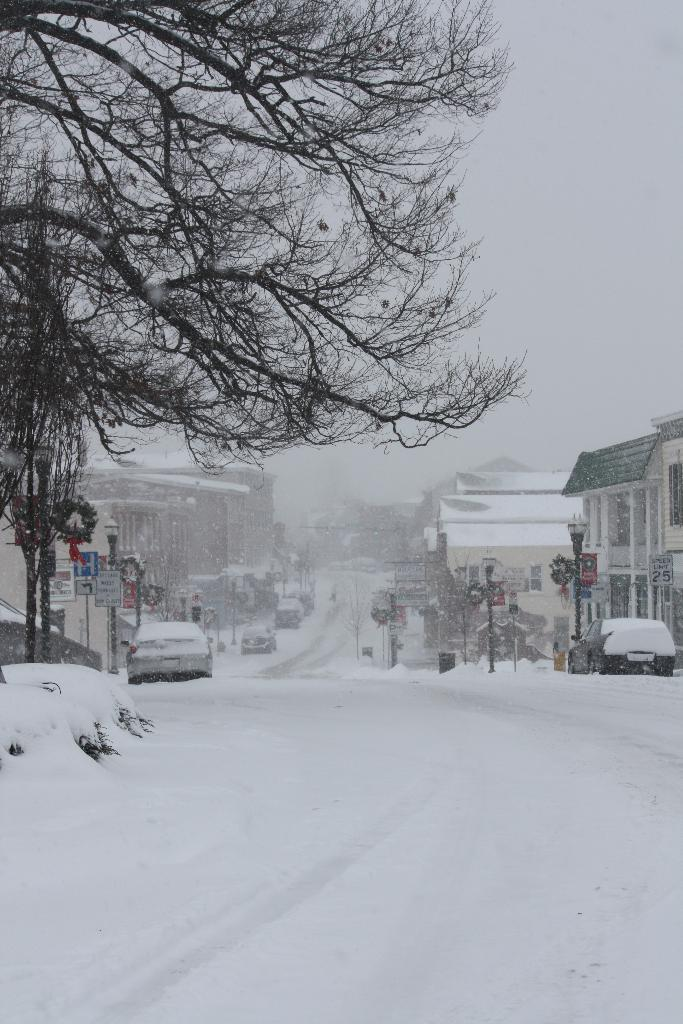What type of natural elements can be seen in the image? There are trees in the image. What man-made objects are present in the image? Vehicles and street lights are visible in the image. How are the buildings in the image affected by the weather? The buildings are covered with snow in the image. What can be seen in the background of the image? The sky is visible in the background of the image. What type of string is being used by the army in the image? There is no army or string present in the image. What type of magic is being performed by the buildings in the image? There is no magic or magical elements present in the image; the buildings are simply covered with snow. 